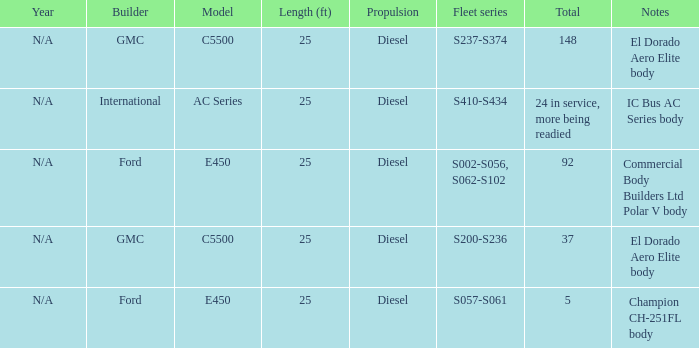What are the notes for Ford when the total is 5? Champion CH-251FL body. 